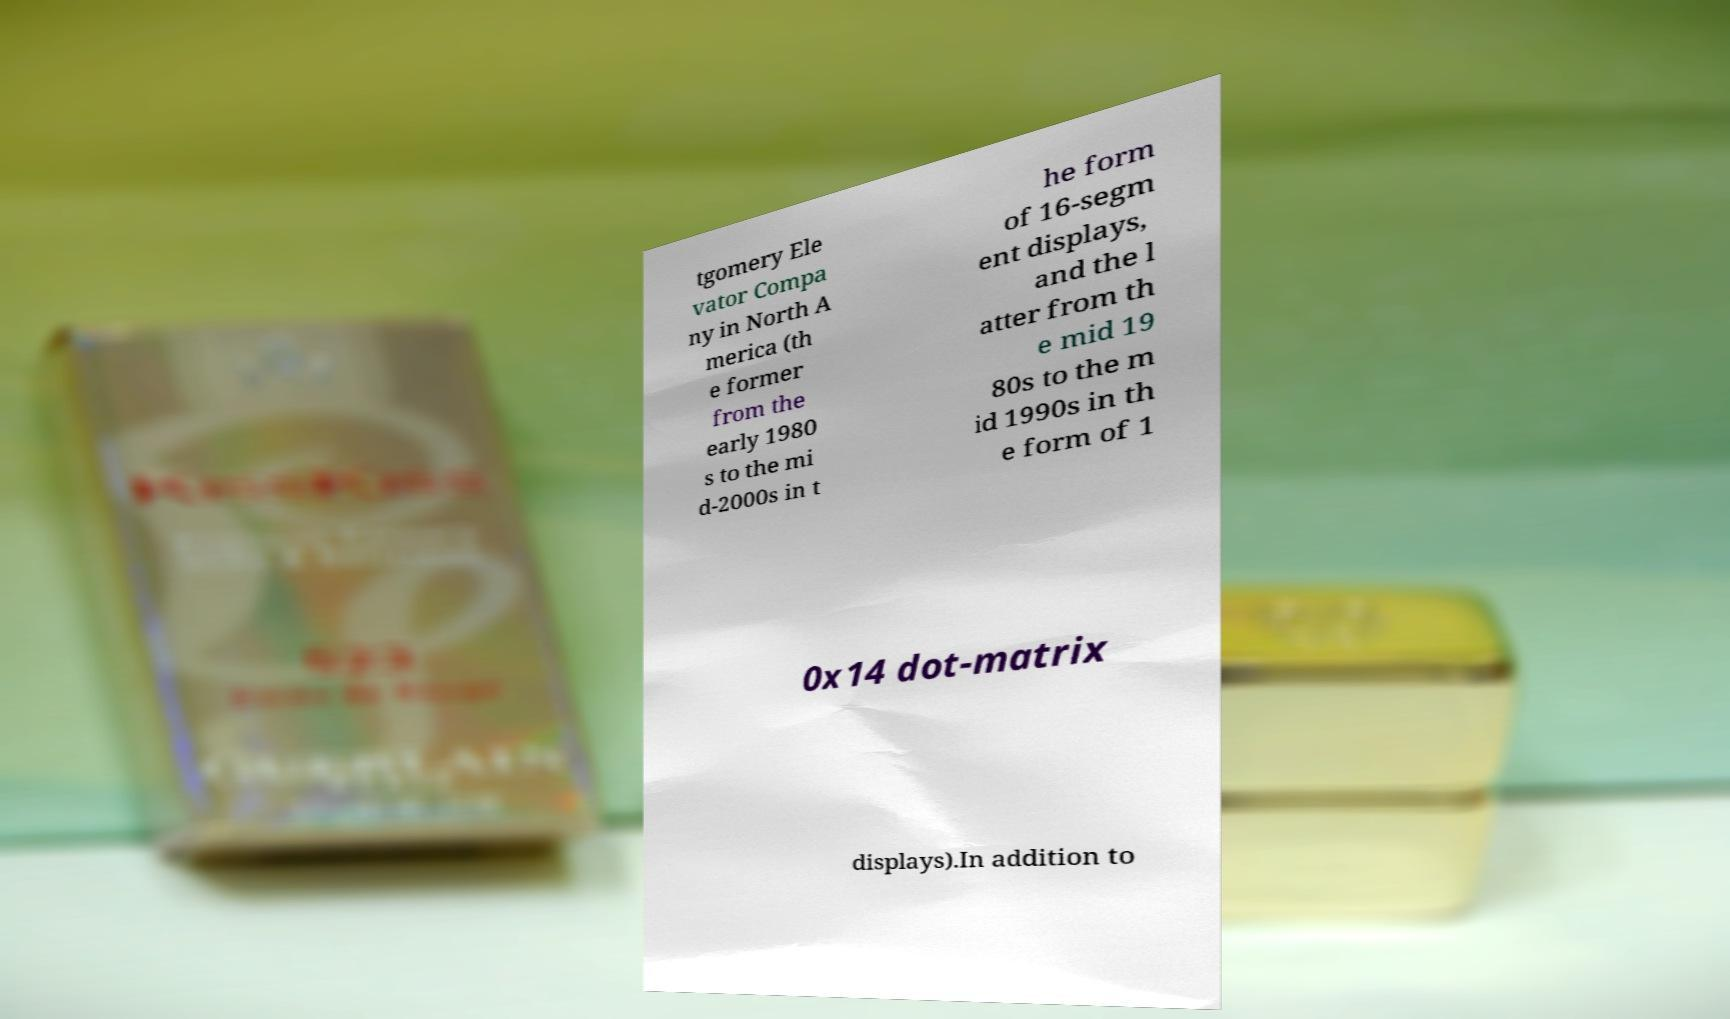There's text embedded in this image that I need extracted. Can you transcribe it verbatim? tgomery Ele vator Compa ny in North A merica (th e former from the early 1980 s to the mi d-2000s in t he form of 16-segm ent displays, and the l atter from th e mid 19 80s to the m id 1990s in th e form of 1 0x14 dot-matrix displays).In addition to 